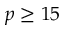Convert formula to latex. <formula><loc_0><loc_0><loc_500><loc_500>p \geq 1 5</formula> 